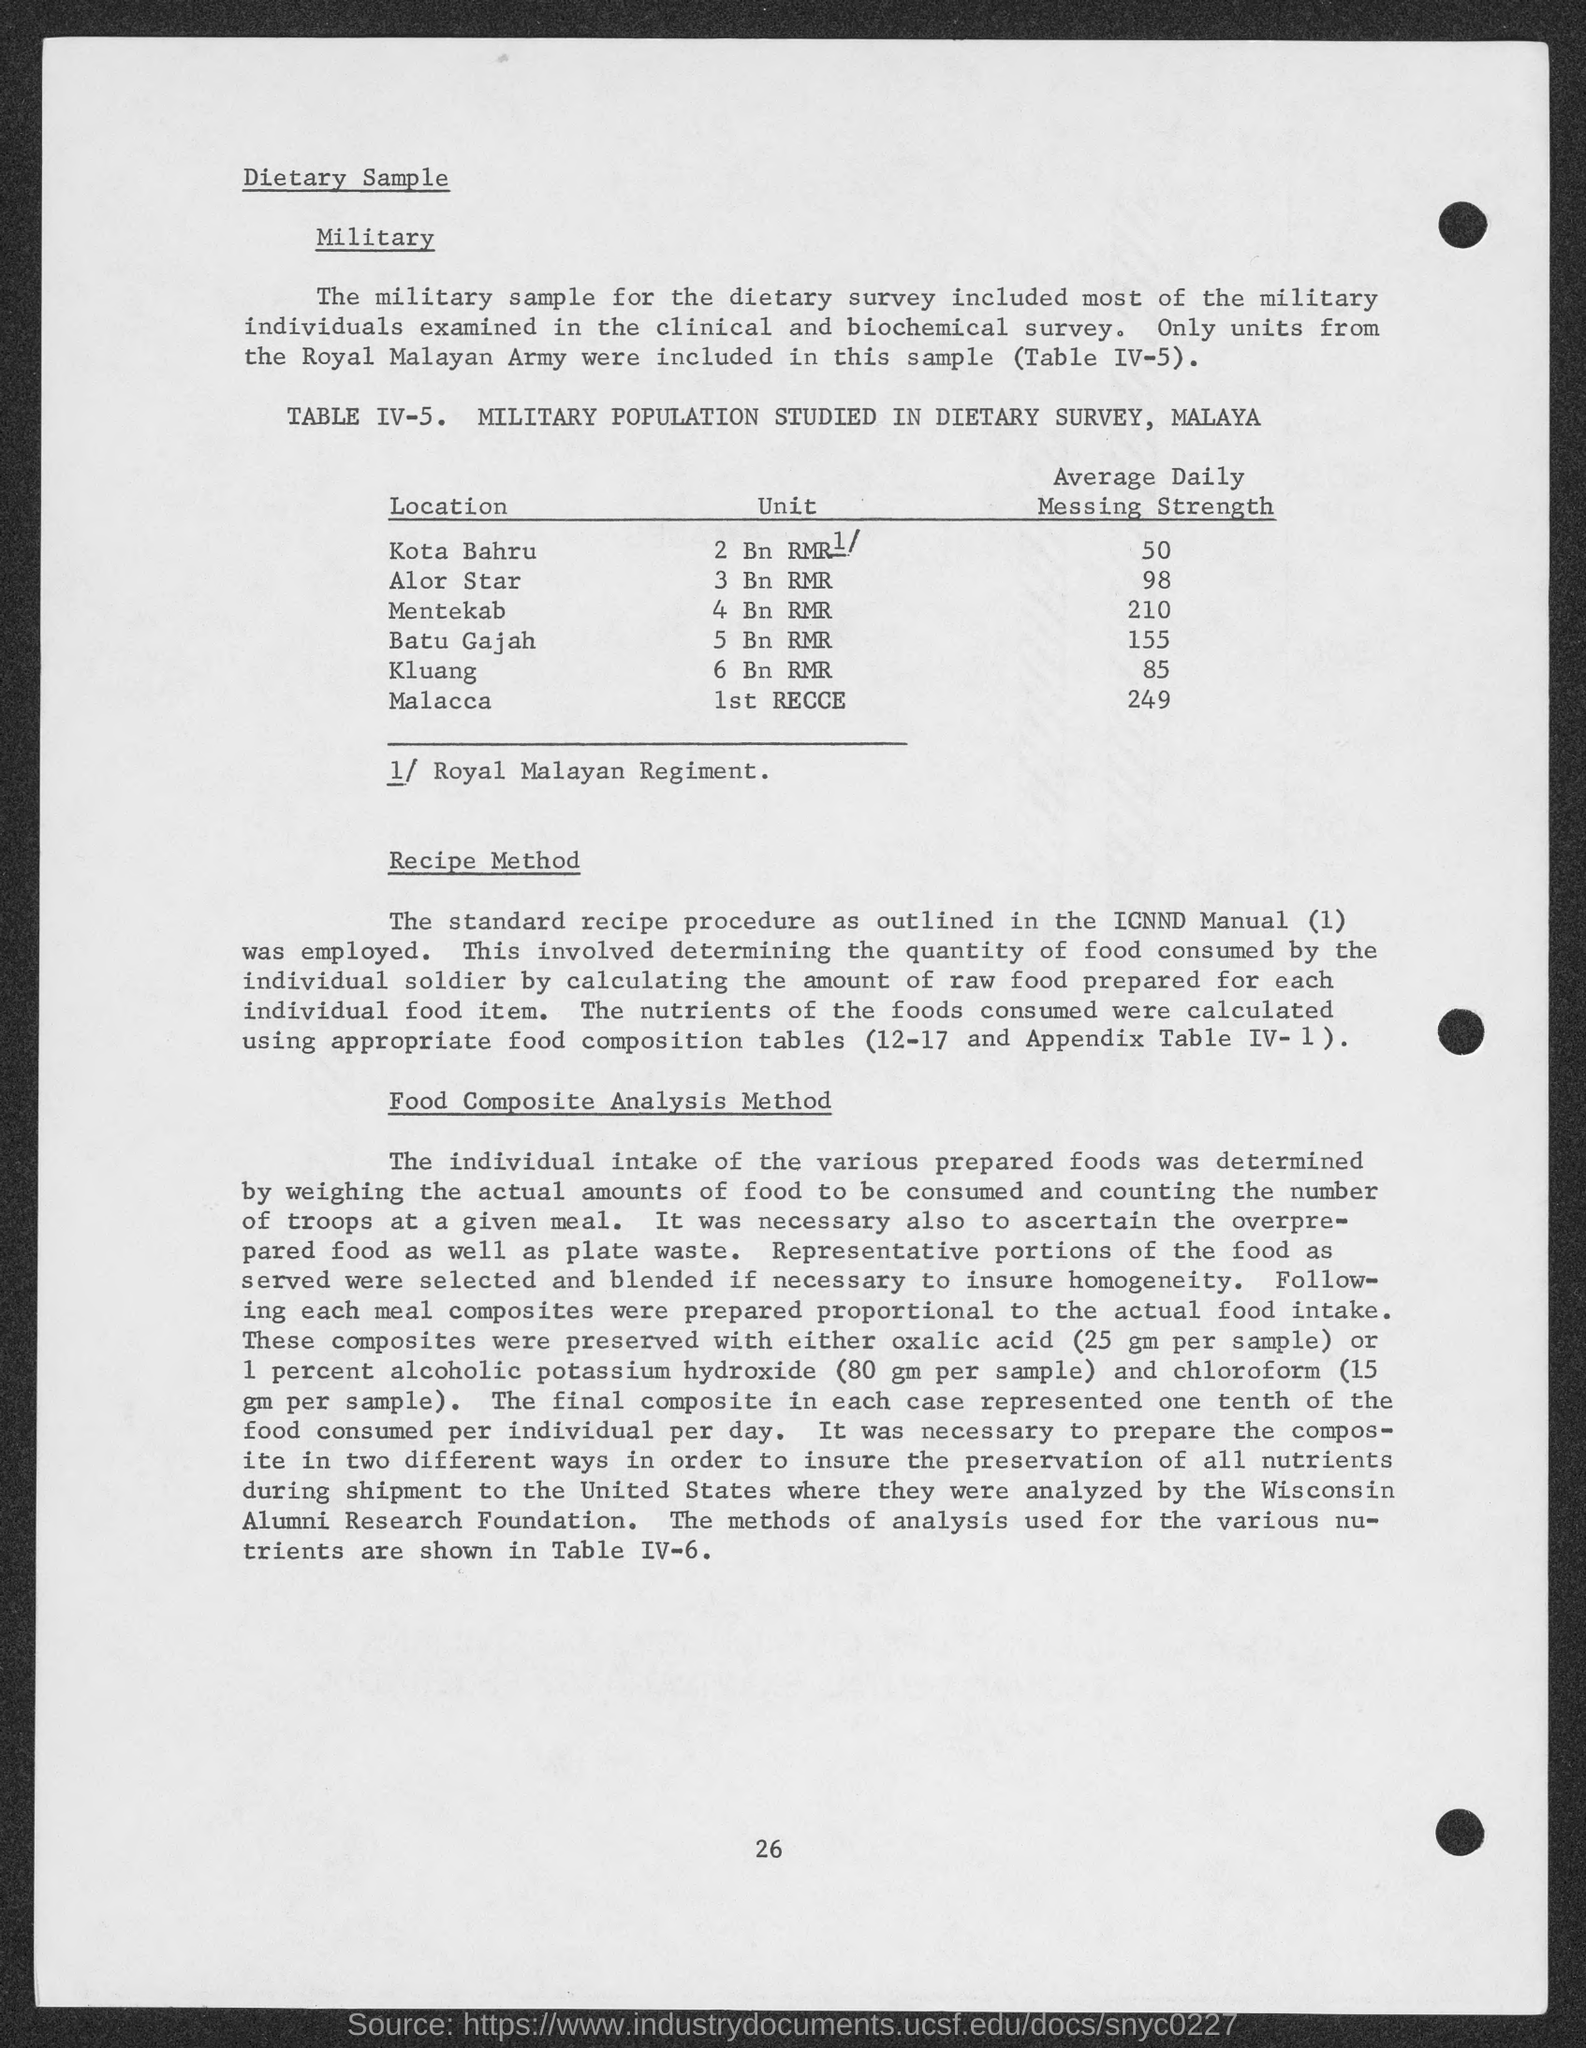List a handful of essential elements in this visual. The average daily messing strength in Kluang is 85. The average daily messing strength for Mentekab is 210. I, 1st Recce, have determined that the unit for Malacca is not known. Batu Gajah is equivalent to 5 billion RMR. The average daily messing strength for Kota Bahru is 50. 